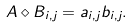Convert formula to latex. <formula><loc_0><loc_0><loc_500><loc_500>A \diamond B _ { i , j } = a _ { i , j } b _ { i , j } .</formula> 